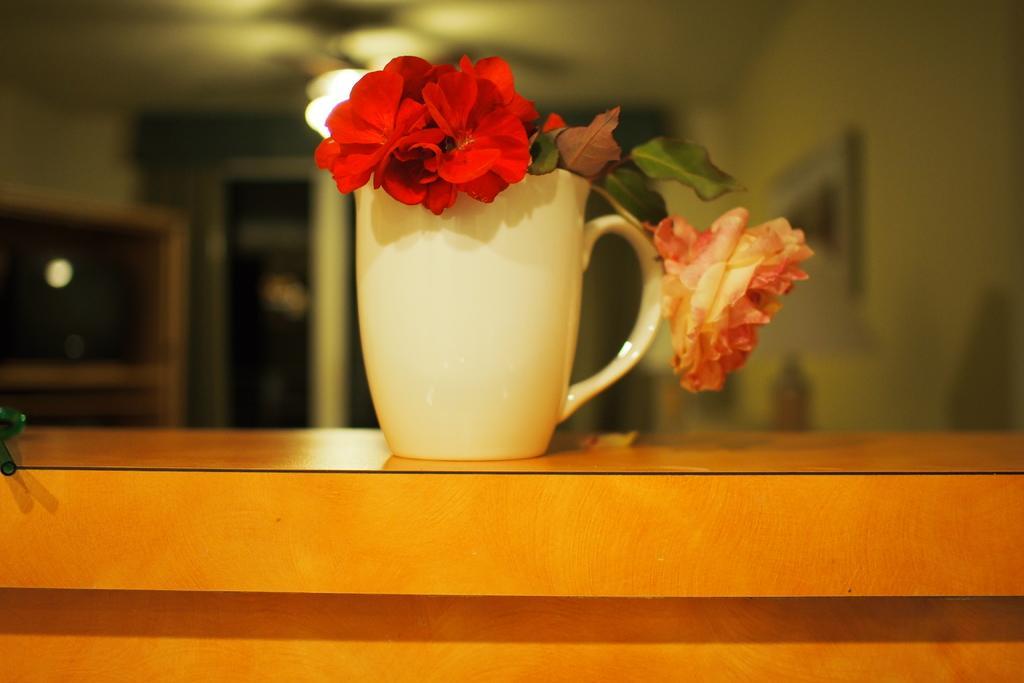How would you summarize this image in a sentence or two? In this picture we can see a cup. And there are some flowers. And this is the light. 